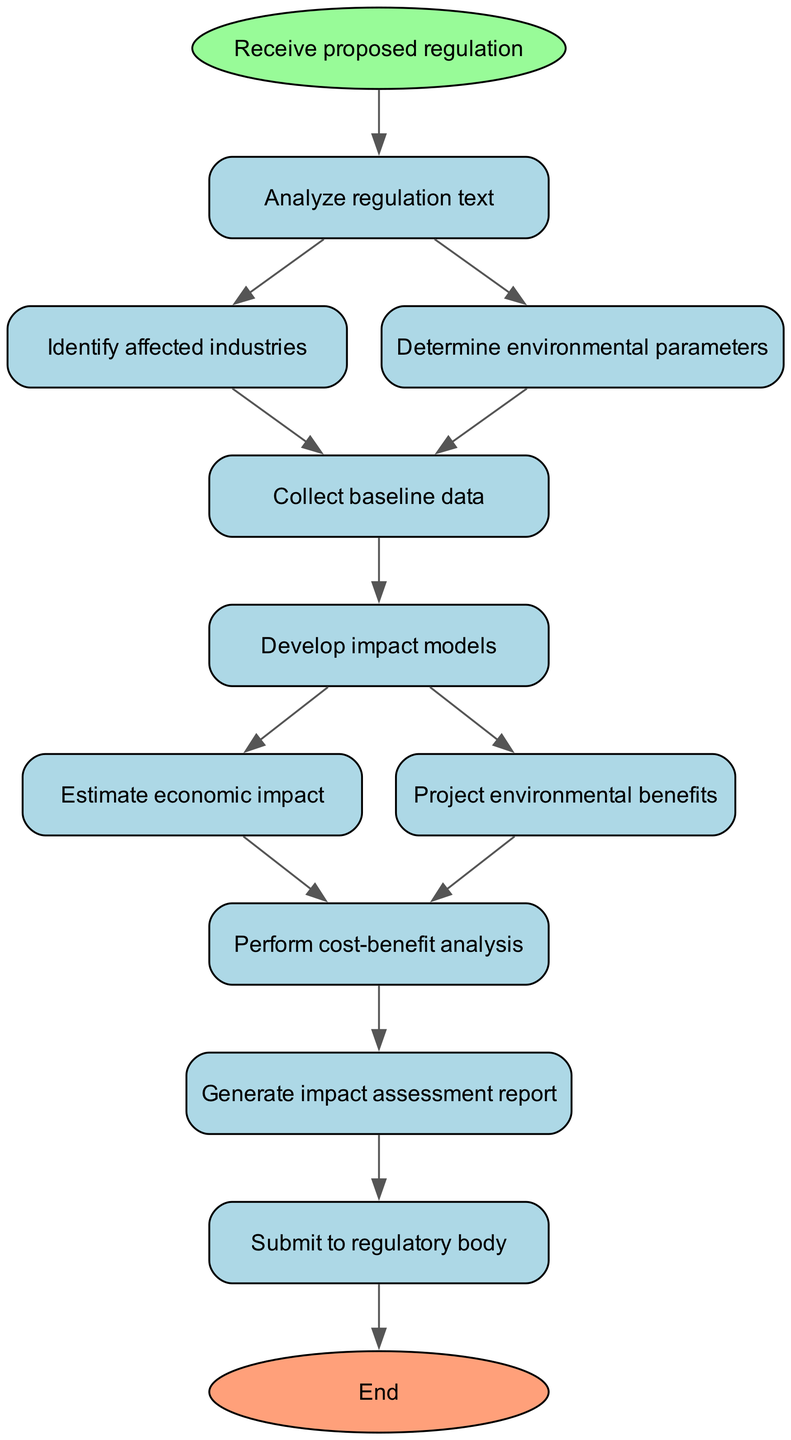What is the starting point of the flowchart? The flowchart begins with the node labeled "Receive proposed regulation," which is indicated as the starting point before any analysis occurs.
Answer: Receive proposed regulation How many nodes are present in the flowchart? By counting each unique process or decision from the start node to the end node, there are a total of 11 nodes in the flowchart.
Answer: 11 What is the final step of the process? The last action in the flowchart is "Submit to regulatory body," which signifies the completion of the assessment process.
Answer: Submit to regulatory body What text is found in node 5? Node 5 contains the text "Develop impact models," which describes a crucial step following the collection of baseline data.
Answer: Develop impact models Which node identifies affected industries? Node 2, labeled "Identify affected industries," specifically focuses on determining which sectors will be impacted by the proposed regulations.
Answer: Identify affected industries What action follows the estimation of economic impact? After "Estimate economic impact," which is node 6, the subsequent action is "Perform cost-benefit analysis," identified as node 8.
Answer: Perform cost-benefit analysis What is the relationship between node 1 and node 2? Node 1 (Analyze regulation text) leads directly to node 2 (Identify affected industries) as the next step in the flow of the diagram. This indicates that after analyzing the regulation, the affected industries are identified.
Answer: Leads to Which two nodes come after collecting baseline data? Following "Collect baseline data" (node 4), the flow proceeds to two separate nodes: "Develop impact models" (node 5) and "Perform cost-benefit analysis" (node 8).
Answer: Develop impact models and Perform cost-benefit analysis What type of analysis occurs after projecting environmental benefits? After projecting environmental benefits in node 7, the next step is a "Perform cost-benefit analysis" as noted in node 8. This relates to evaluating the advantages versus the costs associated with the regulations.
Answer: Perform cost-benefit analysis 